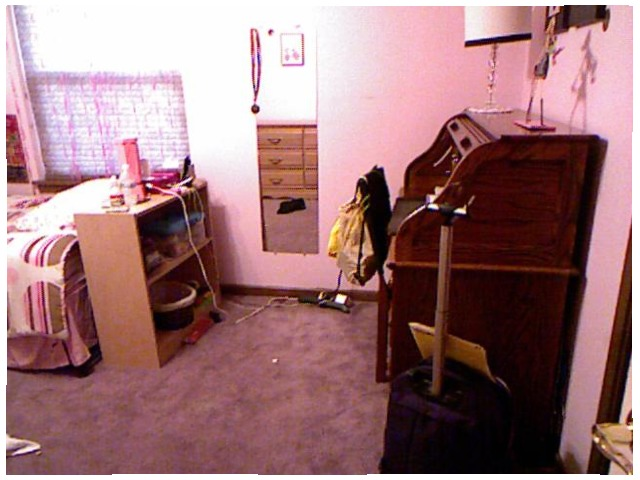<image>
Is the table lamp under the bed? No. The table lamp is not positioned under the bed. The vertical relationship between these objects is different. Is there a dresser in the mirror? Yes. The dresser is contained within or inside the mirror, showing a containment relationship. 